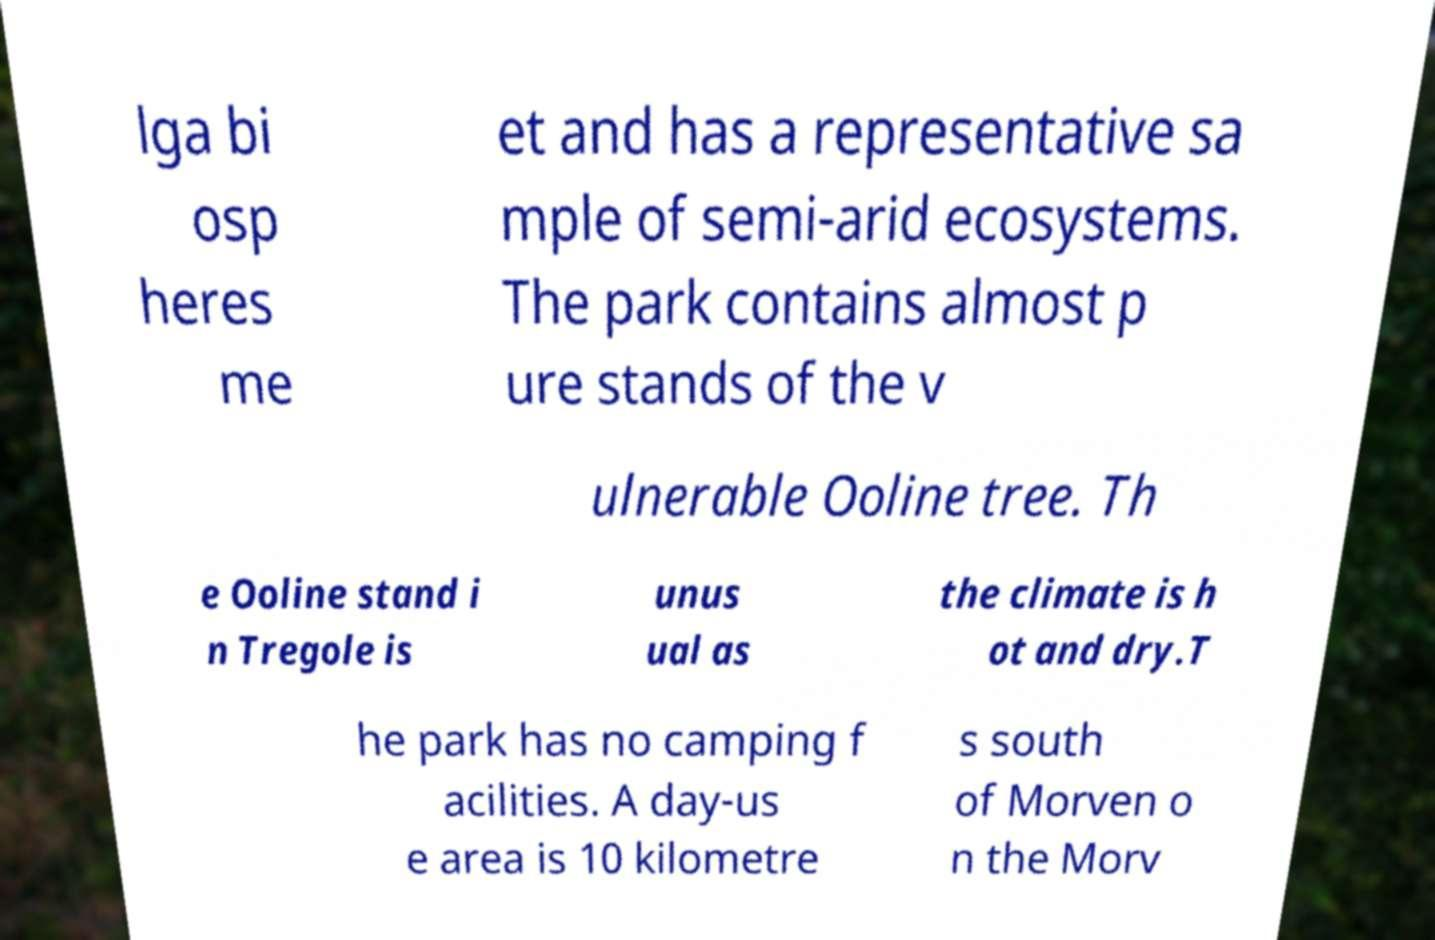For documentation purposes, I need the text within this image transcribed. Could you provide that? lga bi osp heres me et and has a representative sa mple of semi-arid ecosystems. The park contains almost p ure stands of the v ulnerable Ooline tree. Th e Ooline stand i n Tregole is unus ual as the climate is h ot and dry.T he park has no camping f acilities. A day-us e area is 10 kilometre s south of Morven o n the Morv 